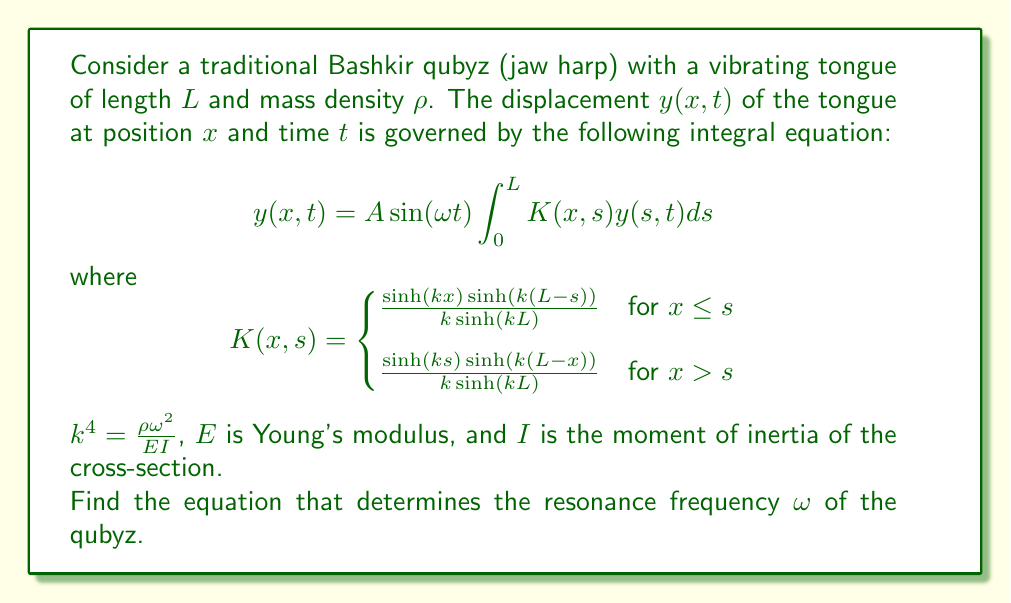Provide a solution to this math problem. To solve this integral equation and find the resonance frequency, we'll follow these steps:

1) First, we assume a solution of the form $y(x,t) = Y(x)\sin(\omega t)$. Substituting this into the original equation:

   $$Y(x)\sin(\omega t) = A\sin(\omega t)\int_0^L K(x,s)Y(s)ds$$

2) The $\sin(\omega t)$ terms cancel out, leaving us with:

   $$Y(x) = A\int_0^L K(x,s)Y(s)ds$$

3) This is a homogeneous Fredholm integral equation of the second kind. For non-trivial solutions, the determinant of the kernel must be zero. In other words, we need:

   $$\det(I - A\lambda_n) = 0$$

   where $I$ is the identity operator and $\lambda_n$ are the eigenvalues of the integral operator.

4) For this specific kernel $K(x,s)$, it can be shown that the eigenvalues are given by:

   $$\lambda_n = \frac{1}{\cosh(kL) - \cos(kL)}$$

5) Therefore, the resonance condition is:

   $$A\lambda_n = 1$$

6) Substituting the expression for $\lambda_n$:

   $$A = \cosh(kL) - \cos(kL)$$

7) Recall that $k^4 = \frac{\rho\omega^2}{EI}$. Substituting this:

   $$A = \cosh(L\sqrt[4]{\frac{\rho\omega^2}{EI}}) - \cos(L\sqrt[4]{\frac{\rho\omega^2}{EI}})$$

This equation implicitly defines the resonance frequency $\omega$ of the qubyz.
Answer: $$A = \cosh(L\sqrt[4]{\frac{\rho\omega^2}{EI}}) - \cos(L\sqrt[4]{\frac{\rho\omega^2}{EI}})$$ 